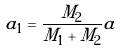<formula> <loc_0><loc_0><loc_500><loc_500>a _ { 1 } = \frac { M _ { 2 } } { M _ { 1 } + M _ { 2 } } a</formula> 